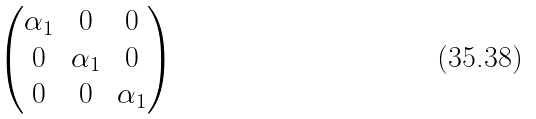<formula> <loc_0><loc_0><loc_500><loc_500>\begin{pmatrix} \alpha _ { 1 } & 0 & 0 \\ 0 & \alpha _ { 1 } & 0 \\ 0 & 0 & \alpha _ { 1 } \\ \end{pmatrix}</formula> 